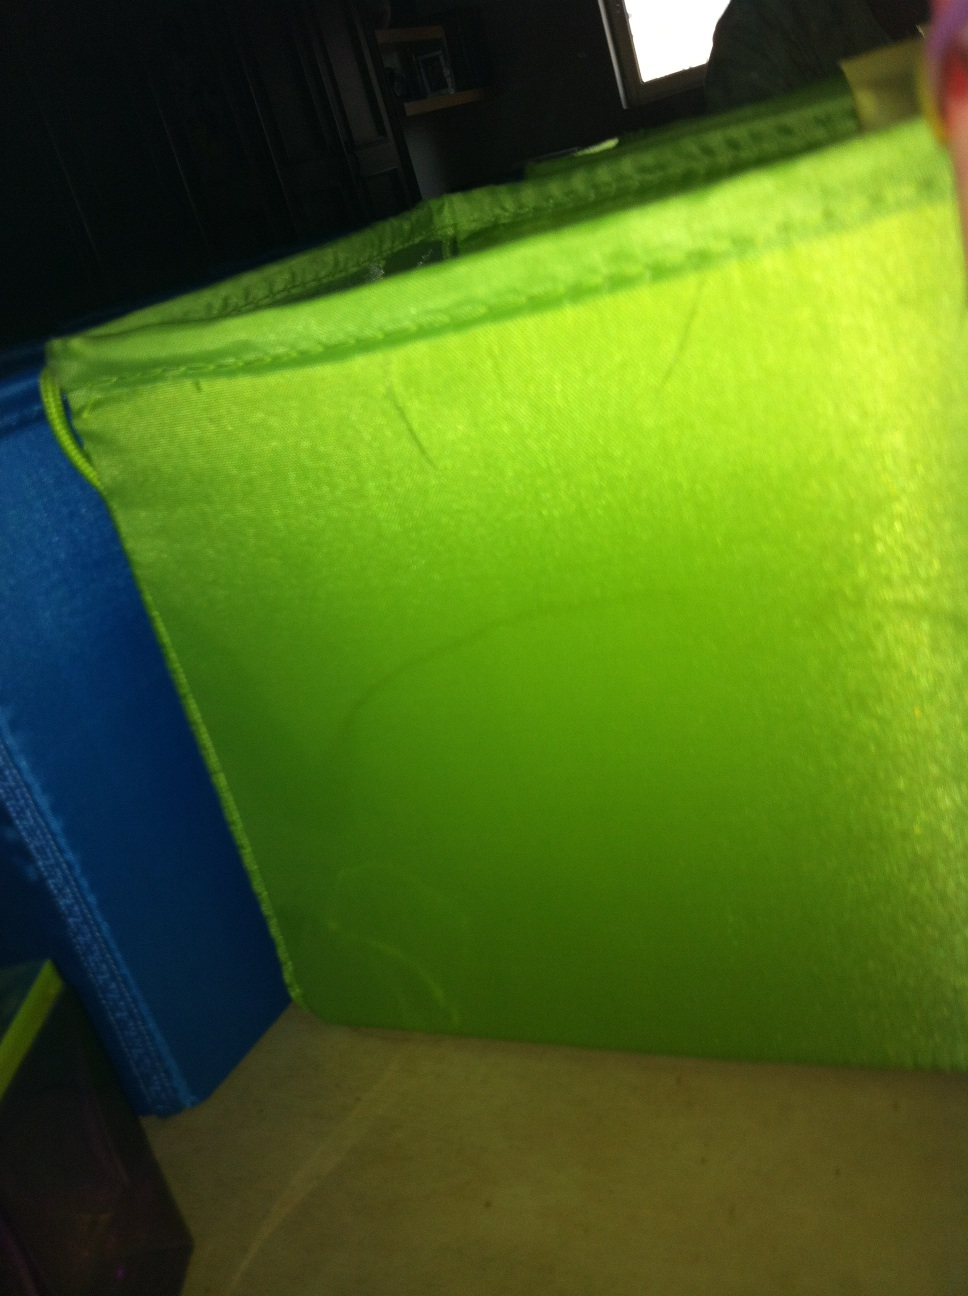Is there anything significant about the position or condition of the green object? The green container appears to be placed casually, perhaps in a state of use. It doesn't seem heavily worn but has visible creases that indicate frequent folding or collapsing. This casual placement might suggest it's used for everyday storage or organizing in a living space, reflecting a functional rather than decorative role. 